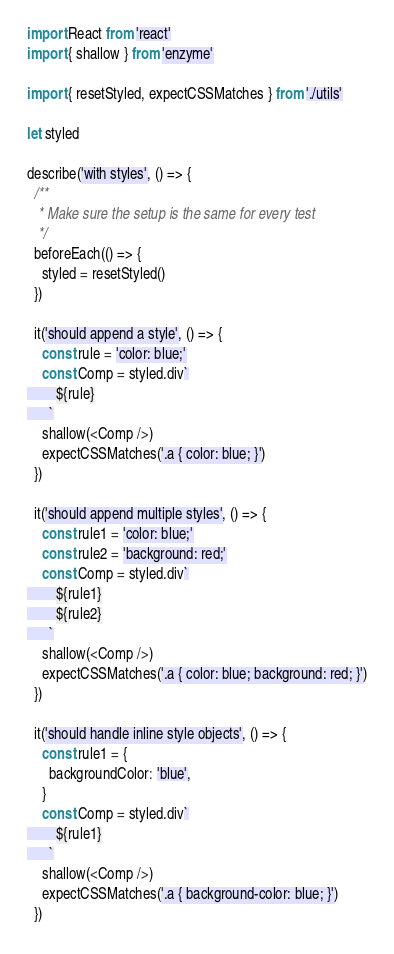<code> <loc_0><loc_0><loc_500><loc_500><_JavaScript_>import React from 'react'
import { shallow } from 'enzyme'

import { resetStyled, expectCSSMatches } from './utils'

let styled

describe('with styles', () => {
  /**
   * Make sure the setup is the same for every test
   */
  beforeEach(() => {
    styled = resetStyled()
  })

  it('should append a style', () => {
    const rule = 'color: blue;'
    const Comp = styled.div`
        ${rule}
      `
    shallow(<Comp />)
    expectCSSMatches('.a { color: blue; }')
  })

  it('should append multiple styles', () => {
    const rule1 = 'color: blue;'
    const rule2 = 'background: red;'
    const Comp = styled.div`
        ${rule1}
        ${rule2}
      `
    shallow(<Comp />)
    expectCSSMatches('.a { color: blue; background: red; }')
  })

  it('should handle inline style objects', () => {
    const rule1 = {
      backgroundColor: 'blue',
    }
    const Comp = styled.div`
        ${rule1}
      `
    shallow(<Comp />)
    expectCSSMatches('.a { background-color: blue; }')
  })
</code> 